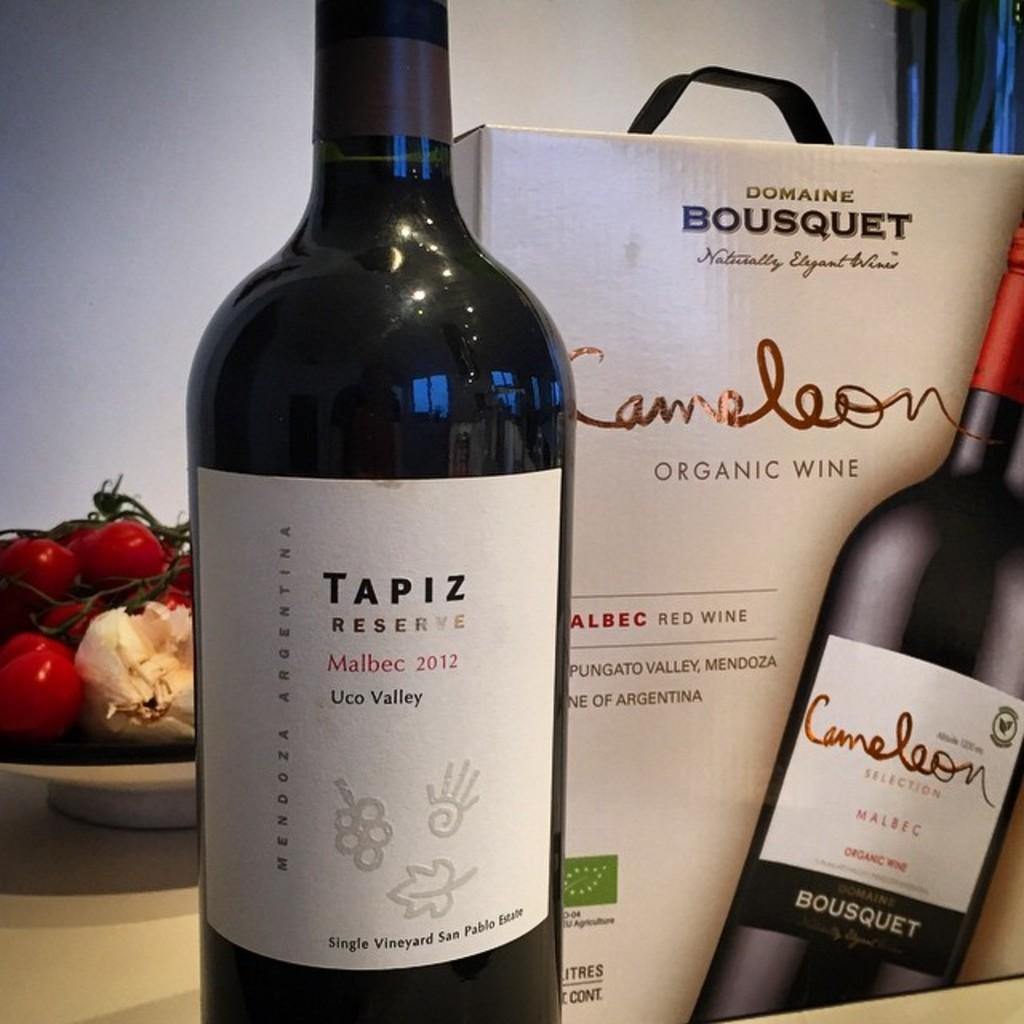<image>
Create a compact narrative representing the image presented. A bottle of Tapiz wine is next to a box of Cameleon wine. 